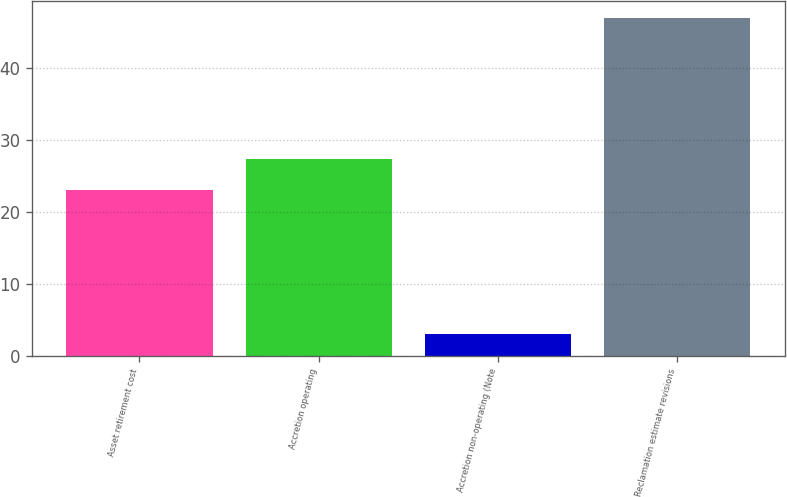Convert chart to OTSL. <chart><loc_0><loc_0><loc_500><loc_500><bar_chart><fcel>Asset retirement cost<fcel>Accretion operating<fcel>Accretion non-operating (Note<fcel>Reclamation estimate revisions<nl><fcel>23<fcel>27.4<fcel>3<fcel>47<nl></chart> 